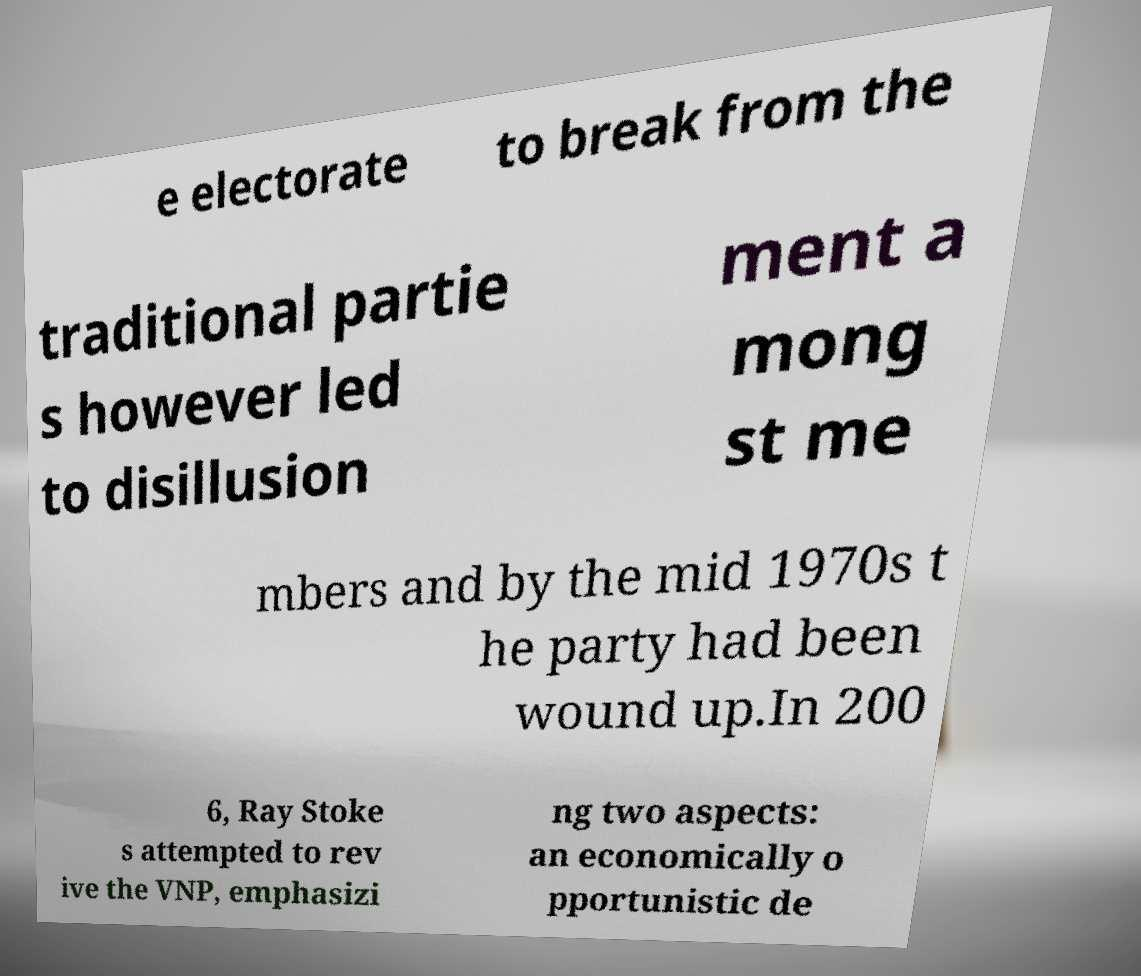Could you extract and type out the text from this image? e electorate to break from the traditional partie s however led to disillusion ment a mong st me mbers and by the mid 1970s t he party had been wound up.In 200 6, Ray Stoke s attempted to rev ive the VNP, emphasizi ng two aspects: an economically o pportunistic de 